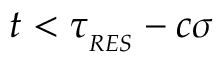<formula> <loc_0><loc_0><loc_500><loc_500>t < \tau _ { _ { R E S } } - c \sigma</formula> 